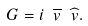Convert formula to latex. <formula><loc_0><loc_0><loc_500><loc_500>G = i \ \overline { v } \ \widehat { v } .</formula> 